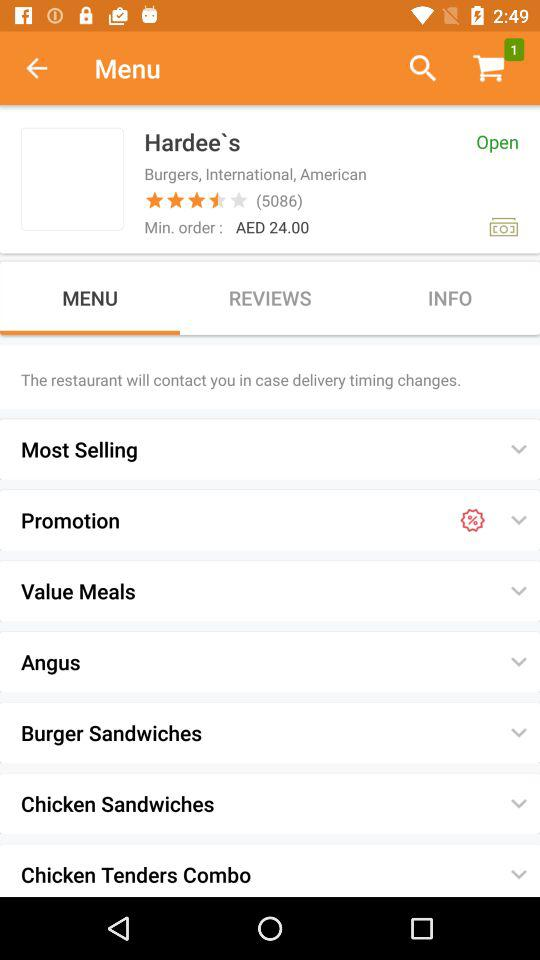How many items are there in the cart? There is 1 item in the cart. 